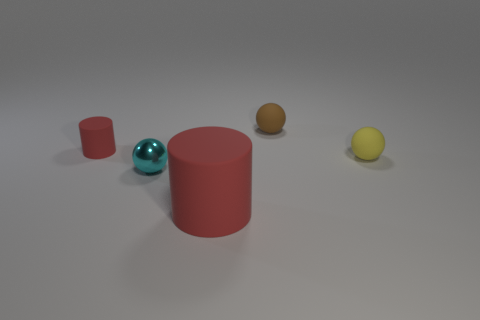What is the shape of the thing that is the same color as the tiny cylinder?
Your answer should be compact. Cylinder. There is a metallic sphere that is the same size as the yellow matte sphere; what is its color?
Make the answer very short. Cyan. How many tiny matte spheres are there?
Give a very brief answer. 2. Is the red object that is right of the cyan metallic thing made of the same material as the brown sphere?
Ensure brevity in your answer.  Yes. What material is the small ball that is on the left side of the small yellow rubber thing and behind the metallic thing?
Provide a short and direct response. Rubber. What is the size of the matte cylinder that is the same color as the large thing?
Provide a short and direct response. Small. What is the material of the cylinder behind the small sphere that is right of the brown rubber sphere?
Keep it short and to the point. Rubber. There is a red matte thing in front of the tiny red matte object that is on the left side of the brown thing behind the big red rubber cylinder; what size is it?
Your response must be concise. Large. What number of small yellow spheres have the same material as the brown sphere?
Offer a terse response. 1. There is a sphere that is in front of the tiny rubber object right of the small brown rubber object; what color is it?
Give a very brief answer. Cyan. 